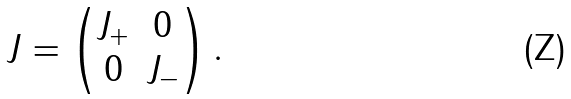Convert formula to latex. <formula><loc_0><loc_0><loc_500><loc_500>J = \begin{pmatrix} J _ { + } & 0 \\ 0 & J _ { - } \end{pmatrix} .</formula> 